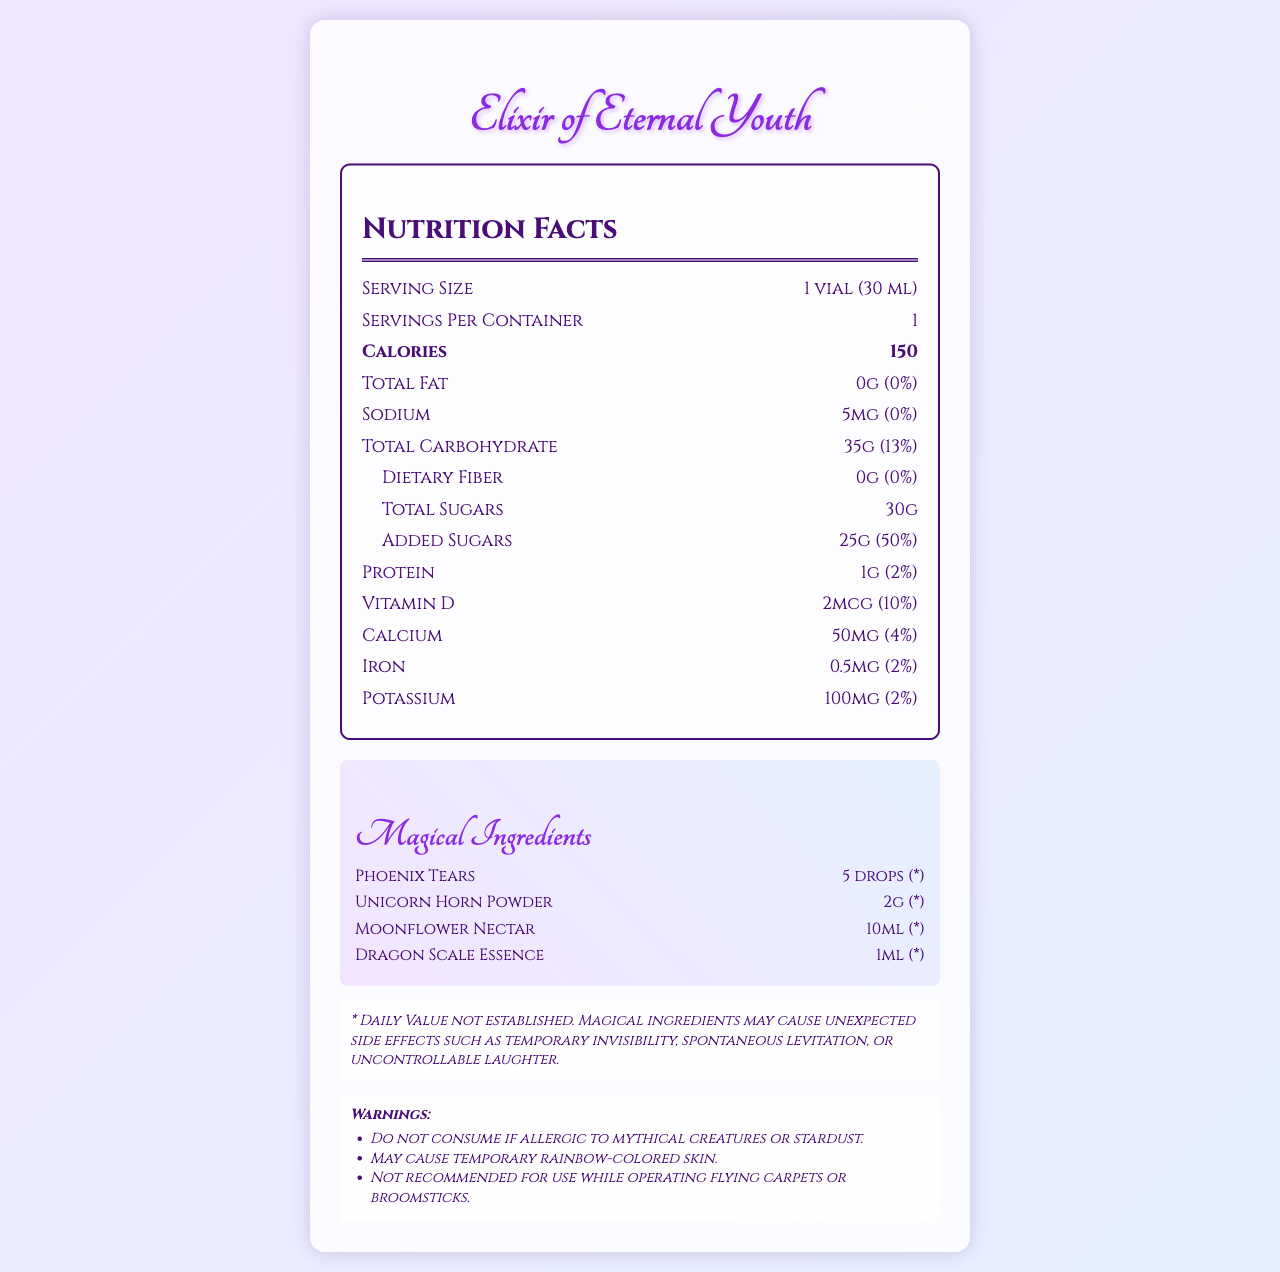what is the serving size of the "Elixir of Eternal Youth"? The serving size is clearly indicated in the document as "1 vial (30 ml)".
Answer: 1 vial (30 ml) how many calories are in one serving of the "Elixir of Eternal Youth"? The document states that the elixir contains 150 calories per serving.
Answer: 150 calories what amount of total sugars is in one vial of this elixir? The total sugars in one serving are listed as 30g.
Answer: 30g how much sodium does this potion contain per serving? The document specifies that there are 5mg of sodium in each serving.
Answer: 5mg identify one of the magical ingredients in the elixir The magical ingredients section lists Phoenix Tears as one of the components of the elixir.
Answer: Phoenix Tears which of the following is NOT a warning associated with the elixir? A. May cause temporary rainbow-colored skin B. Do not consume if allergic to mythical creatures or stardust C. May induce fire-breathing ability The correct answer is C, as it is not listed among the warnings in the document.
Answer: C what is the daily value percentage of added sugars in one vial? A. 25% B. 50% C. 75% The document states that the daily value for added sugars is 50%.
Answer: B does the elixir contain any protein? The document indicates that the elixir has 1g of protein per serving, which is 2% of the daily value.
Answer: Yes describe the main idea of the document The document is a detailed representation of the nutritional and magical components of the "Elixir of Eternal Youth," including caloric content, fat, sodium, carbohydrates, and vitamins. Additionally, it lists unique magical ingredients, several warnings, and artistic guidelines for the illustrator.
Answer: The document provides the nutrition facts and magical ingredient details of the "Elixir of Eternal Youth," outlining specific nutritional values, magical components, warnings, and notes for the illustrator. what happens if you consume this potion and are allergic to mythical creatures? The document includes a warning mentioning that you should not consume the elixir if you are allergic to mythical creatures or stardust.
Answer: You should not consume the potion if allergic. how will the potion's visual elements be affected by the illustrator's notes? The illustrator's notes advise using vibrant colors, adding small illustrations of magical ingredients, incorporating a glow effect, and adding fantasy decorations to emphasize the potion's mystical properties.
Answer: They will include vibrant, shimmering colors, illustrations of magical ingredients, a subtle glow effect, and fantasy-inspired decorations like swirls and stars. how many servings are contained in the elixir bottle? The document states that there is one serving per container.
Answer: 1 what is not specified in the document regarding magical ingredients? The document lists the magical ingredients and their amounts but does not specify the individual magical properties or effects of Phoenix Tears, Unicorn Horn Powder, Moonflower Nectar, or Dragon Scale Essence.
Answer: The specific magical properties or effects of each ingredient 